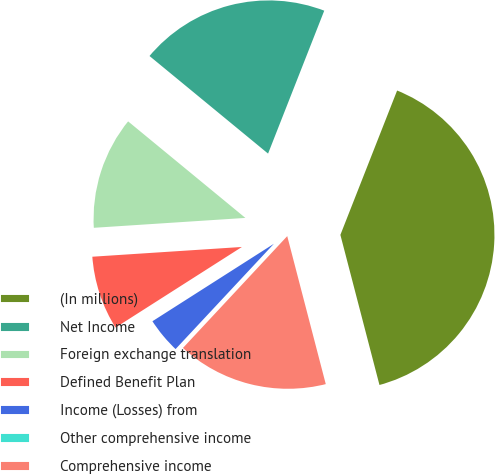<chart> <loc_0><loc_0><loc_500><loc_500><pie_chart><fcel>(In millions)<fcel>Net Income<fcel>Foreign exchange translation<fcel>Defined Benefit Plan<fcel>Income (Losses) from<fcel>Other comprehensive income<fcel>Comprehensive income<nl><fcel>39.99%<fcel>20.0%<fcel>12.0%<fcel>8.0%<fcel>4.01%<fcel>0.01%<fcel>16.0%<nl></chart> 